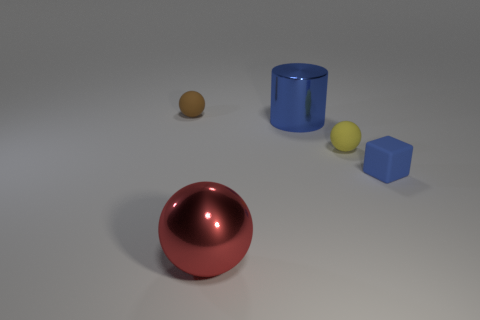Subtract all small yellow balls. How many balls are left? 2 Add 1 large purple things. How many objects exist? 6 Subtract all yellow balls. How many balls are left? 2 Subtract all spheres. How many objects are left? 2 Subtract all blue balls. Subtract all purple cylinders. How many balls are left? 3 Subtract 1 brown spheres. How many objects are left? 4 Subtract all tiny gray rubber blocks. Subtract all big red metallic spheres. How many objects are left? 4 Add 3 red objects. How many red objects are left? 4 Add 1 small blue matte objects. How many small blue matte objects exist? 2 